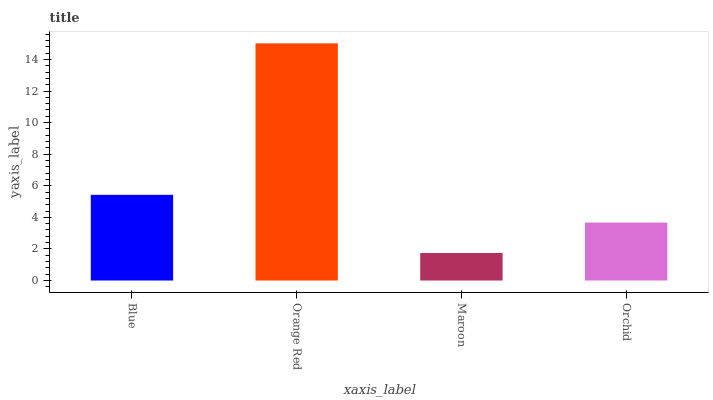Is Maroon the minimum?
Answer yes or no. Yes. Is Orange Red the maximum?
Answer yes or no. Yes. Is Orange Red the minimum?
Answer yes or no. No. Is Maroon the maximum?
Answer yes or no. No. Is Orange Red greater than Maroon?
Answer yes or no. Yes. Is Maroon less than Orange Red?
Answer yes or no. Yes. Is Maroon greater than Orange Red?
Answer yes or no. No. Is Orange Red less than Maroon?
Answer yes or no. No. Is Blue the high median?
Answer yes or no. Yes. Is Orchid the low median?
Answer yes or no. Yes. Is Orchid the high median?
Answer yes or no. No. Is Blue the low median?
Answer yes or no. No. 